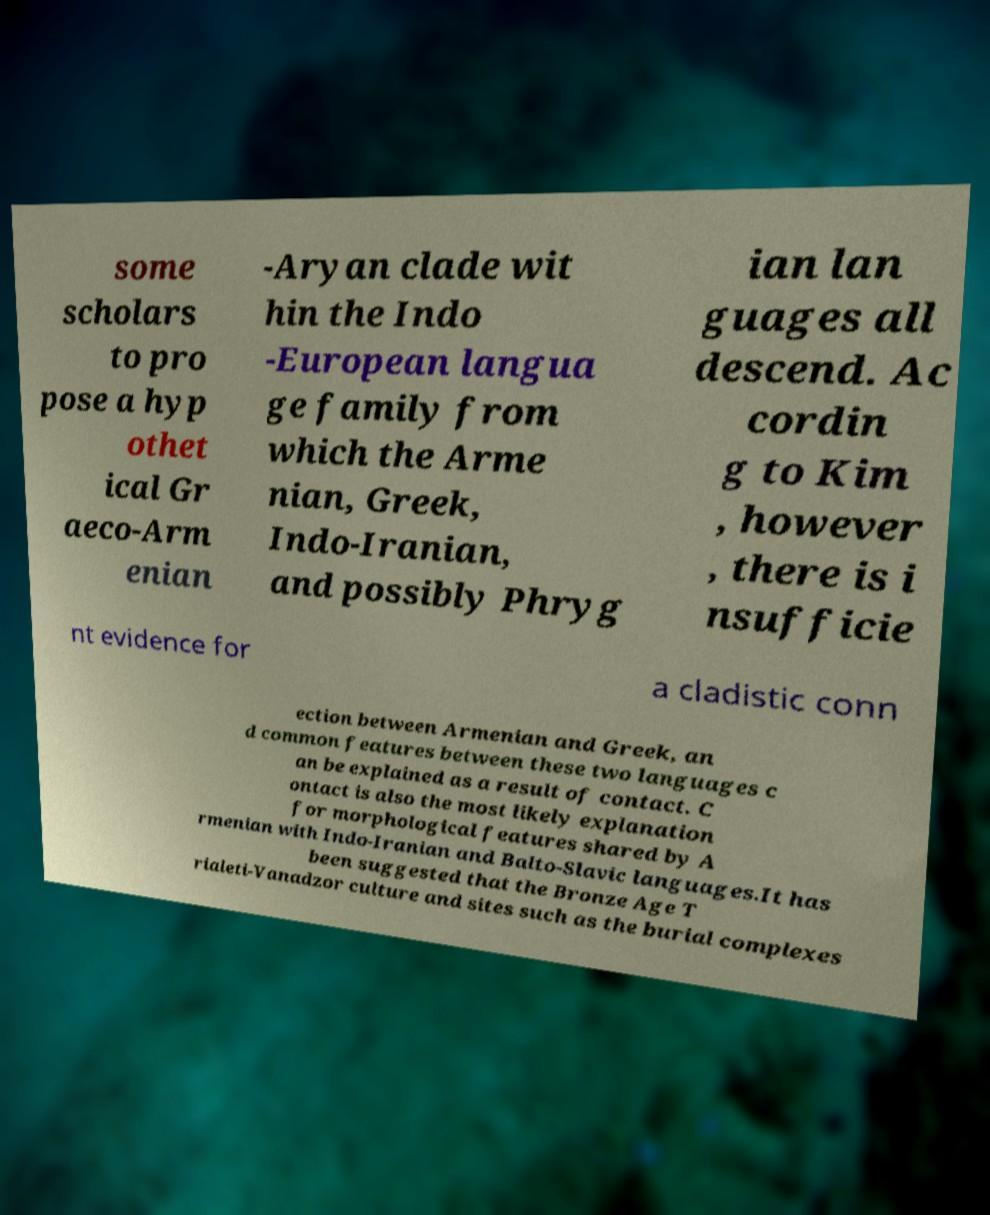I need the written content from this picture converted into text. Can you do that? some scholars to pro pose a hyp othet ical Gr aeco-Arm enian -Aryan clade wit hin the Indo -European langua ge family from which the Arme nian, Greek, Indo-Iranian, and possibly Phryg ian lan guages all descend. Ac cordin g to Kim , however , there is i nsufficie nt evidence for a cladistic conn ection between Armenian and Greek, an d common features between these two languages c an be explained as a result of contact. C ontact is also the most likely explanation for morphological features shared by A rmenian with Indo-Iranian and Balto-Slavic languages.It has been suggested that the Bronze Age T rialeti-Vanadzor culture and sites such as the burial complexes 